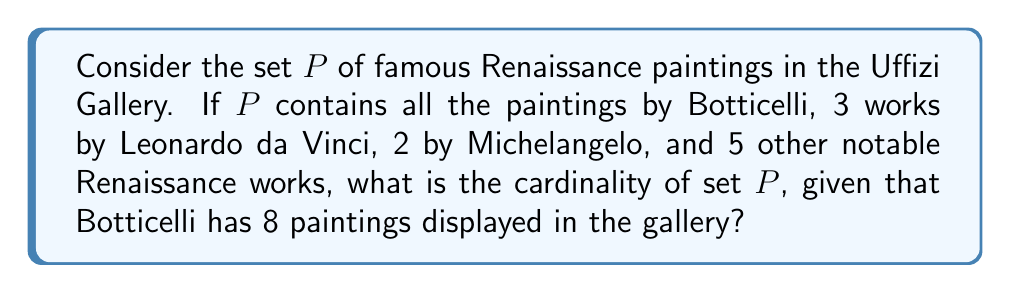Solve this math problem. To determine the cardinality of set $P$, we need to count the total number of elements (paintings) in the set. Let's break it down step by step:

1. Paintings by Botticelli:
   - The question states that $P$ contains all of Botticelli's paintings in the gallery.
   - We are given that Botticelli has 8 paintings displayed.
   - Therefore, $|P_{\text{Botticelli}}| = 8$

2. Paintings by Leonardo da Vinci:
   - The set contains 3 works by Leonardo da Vinci.
   - $|P_{\text{da Vinci}}| = 3$

3. Paintings by Michelangelo:
   - The set contains 2 works by Michelangelo.
   - $|P_{\text{Michelangelo}}| = 2$

4. Other notable Renaissance works:
   - The set contains 5 other notable Renaissance works.
   - $|P_{\text{Other}}| = 5$

To find the cardinality of set $P$, we sum up all these paintings:

$$|P| = |P_{\text{Botticelli}}| + |P_{\text{da Vinci}}| + |P_{\text{Michelangelo}}| + |P_{\text{Other}}|$$

$$|P| = 8 + 3 + 2 + 5$$

$$|P| = 18$$

Therefore, the cardinality of set $P$ is 18.
Answer: $|P| = 18$ 